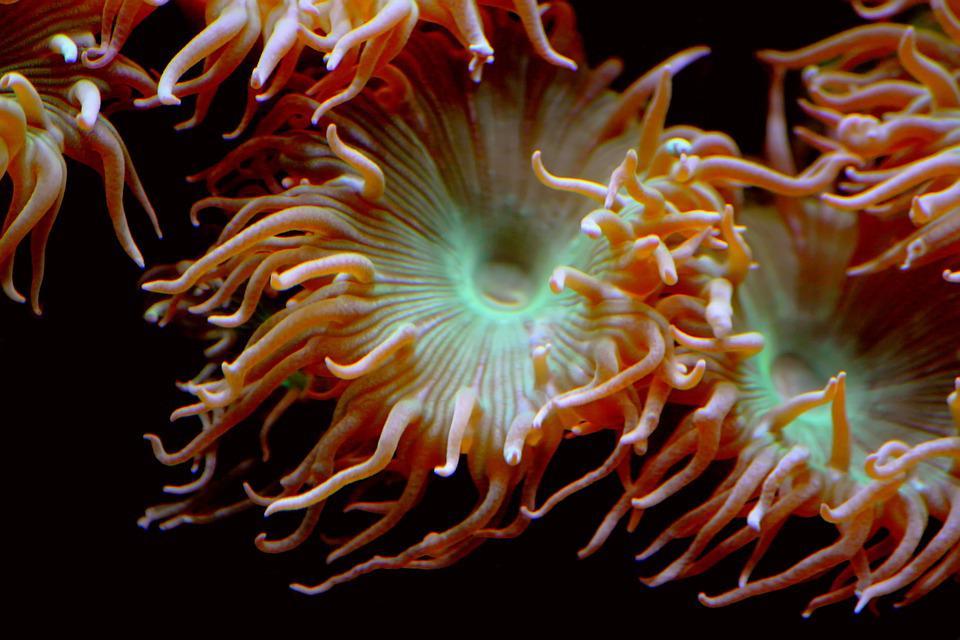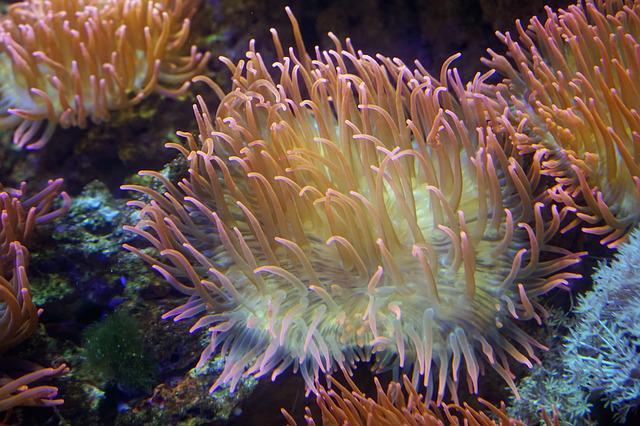The first image is the image on the left, the second image is the image on the right. Examine the images to the left and right. Is the description "The left image contains an animal that is not an anemone." accurate? Answer yes or no. No. 